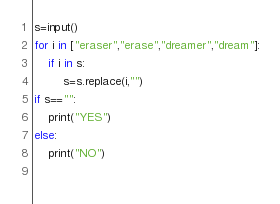<code> <loc_0><loc_0><loc_500><loc_500><_Python_>s=input()
for i in ["eraser","erase","dreamer","dream"]:
    if i in s:
        s=s.replace(i,"")
if s=="":
    print("YES")
else:
    print("NO")
    </code> 